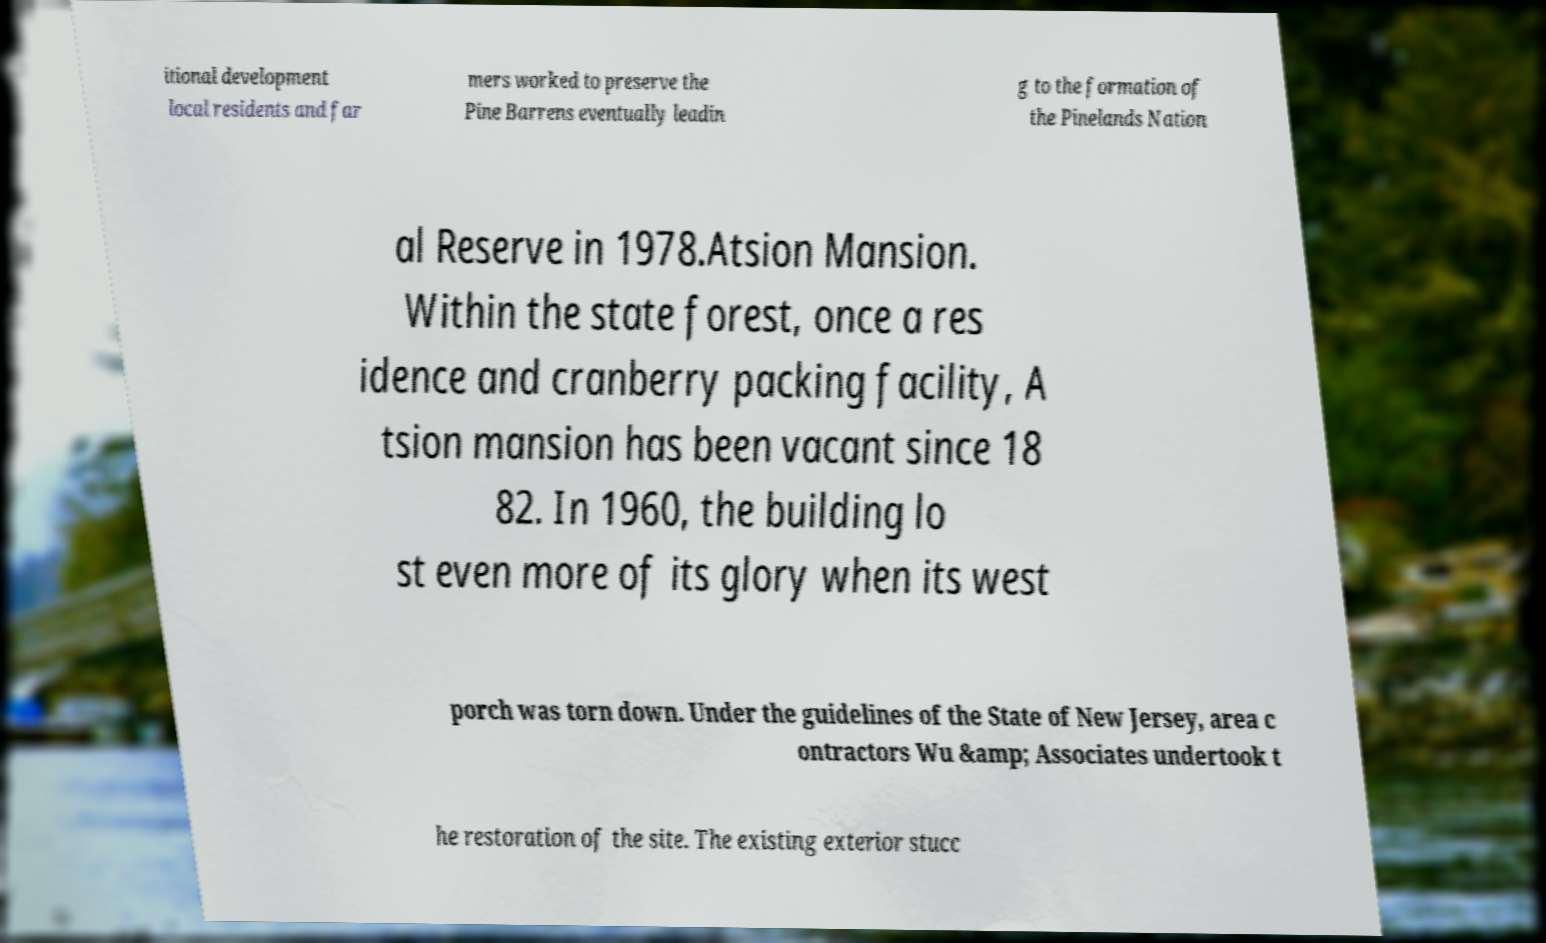Please read and relay the text visible in this image. What does it say? itional development local residents and far mers worked to preserve the Pine Barrens eventually leadin g to the formation of the Pinelands Nation al Reserve in 1978.Atsion Mansion. Within the state forest, once a res idence and cranberry packing facility, A tsion mansion has been vacant since 18 82. In 1960, the building lo st even more of its glory when its west porch was torn down. Under the guidelines of the State of New Jersey, area c ontractors Wu &amp; Associates undertook t he restoration of the site. The existing exterior stucc 